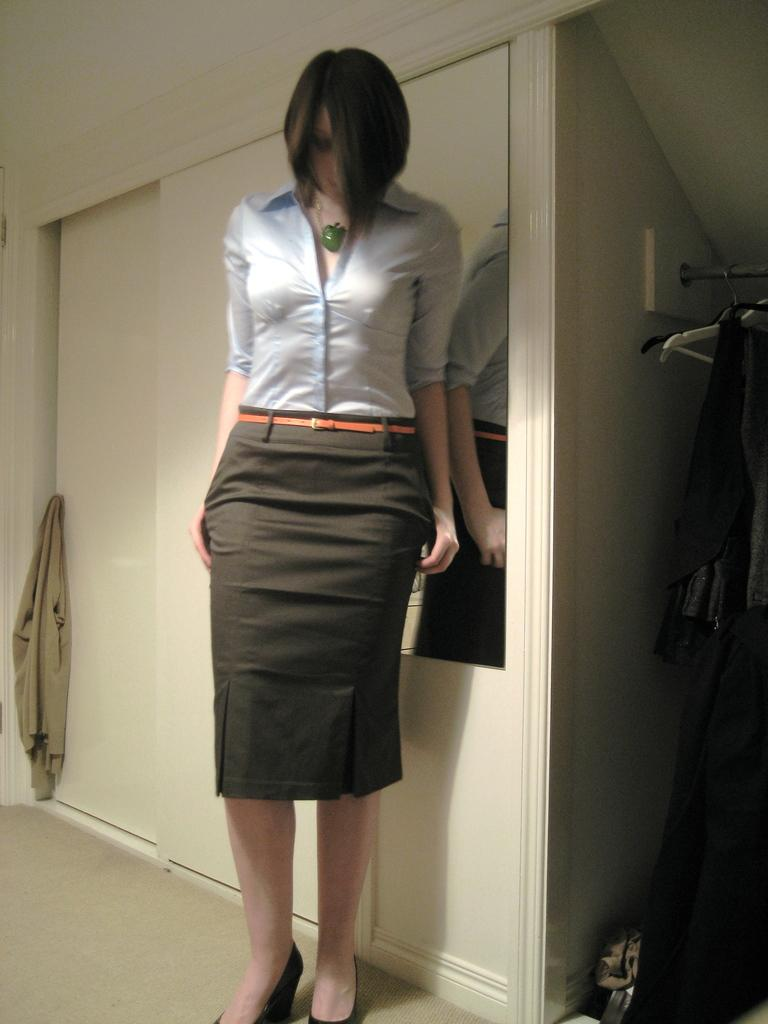What is the main subject of the image? There is a woman standing in the image. Where is the woman standing? The woman is standing on the floor. What can be seen hanging in the image? Clothes are hung on hangers in the image. What type of furniture is present in the image? There is a cupboard in the image. What type of board is the woman using to manage her financial accounts in the image? There is no board or financial accounts present in the image; it only features a woman standing and clothes hung on hangers. How does the woman maintain her health in the image? There is no information about the woman's health or any activities related to health in the image. 